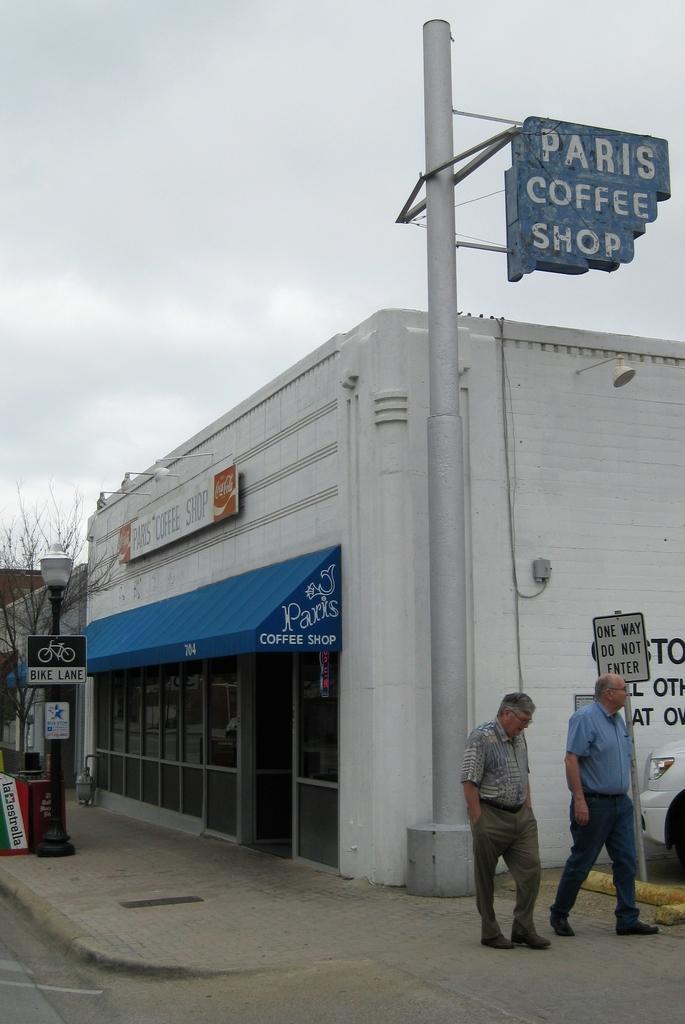Describe this image in one or two sentences. In this picture there are two old man walking on the cobbler stones. Behind there is a white color restaurant shop. In the front there is a silver pole on which Paris coffee is written. In the background we can see a blue caution board and a dry tree. 